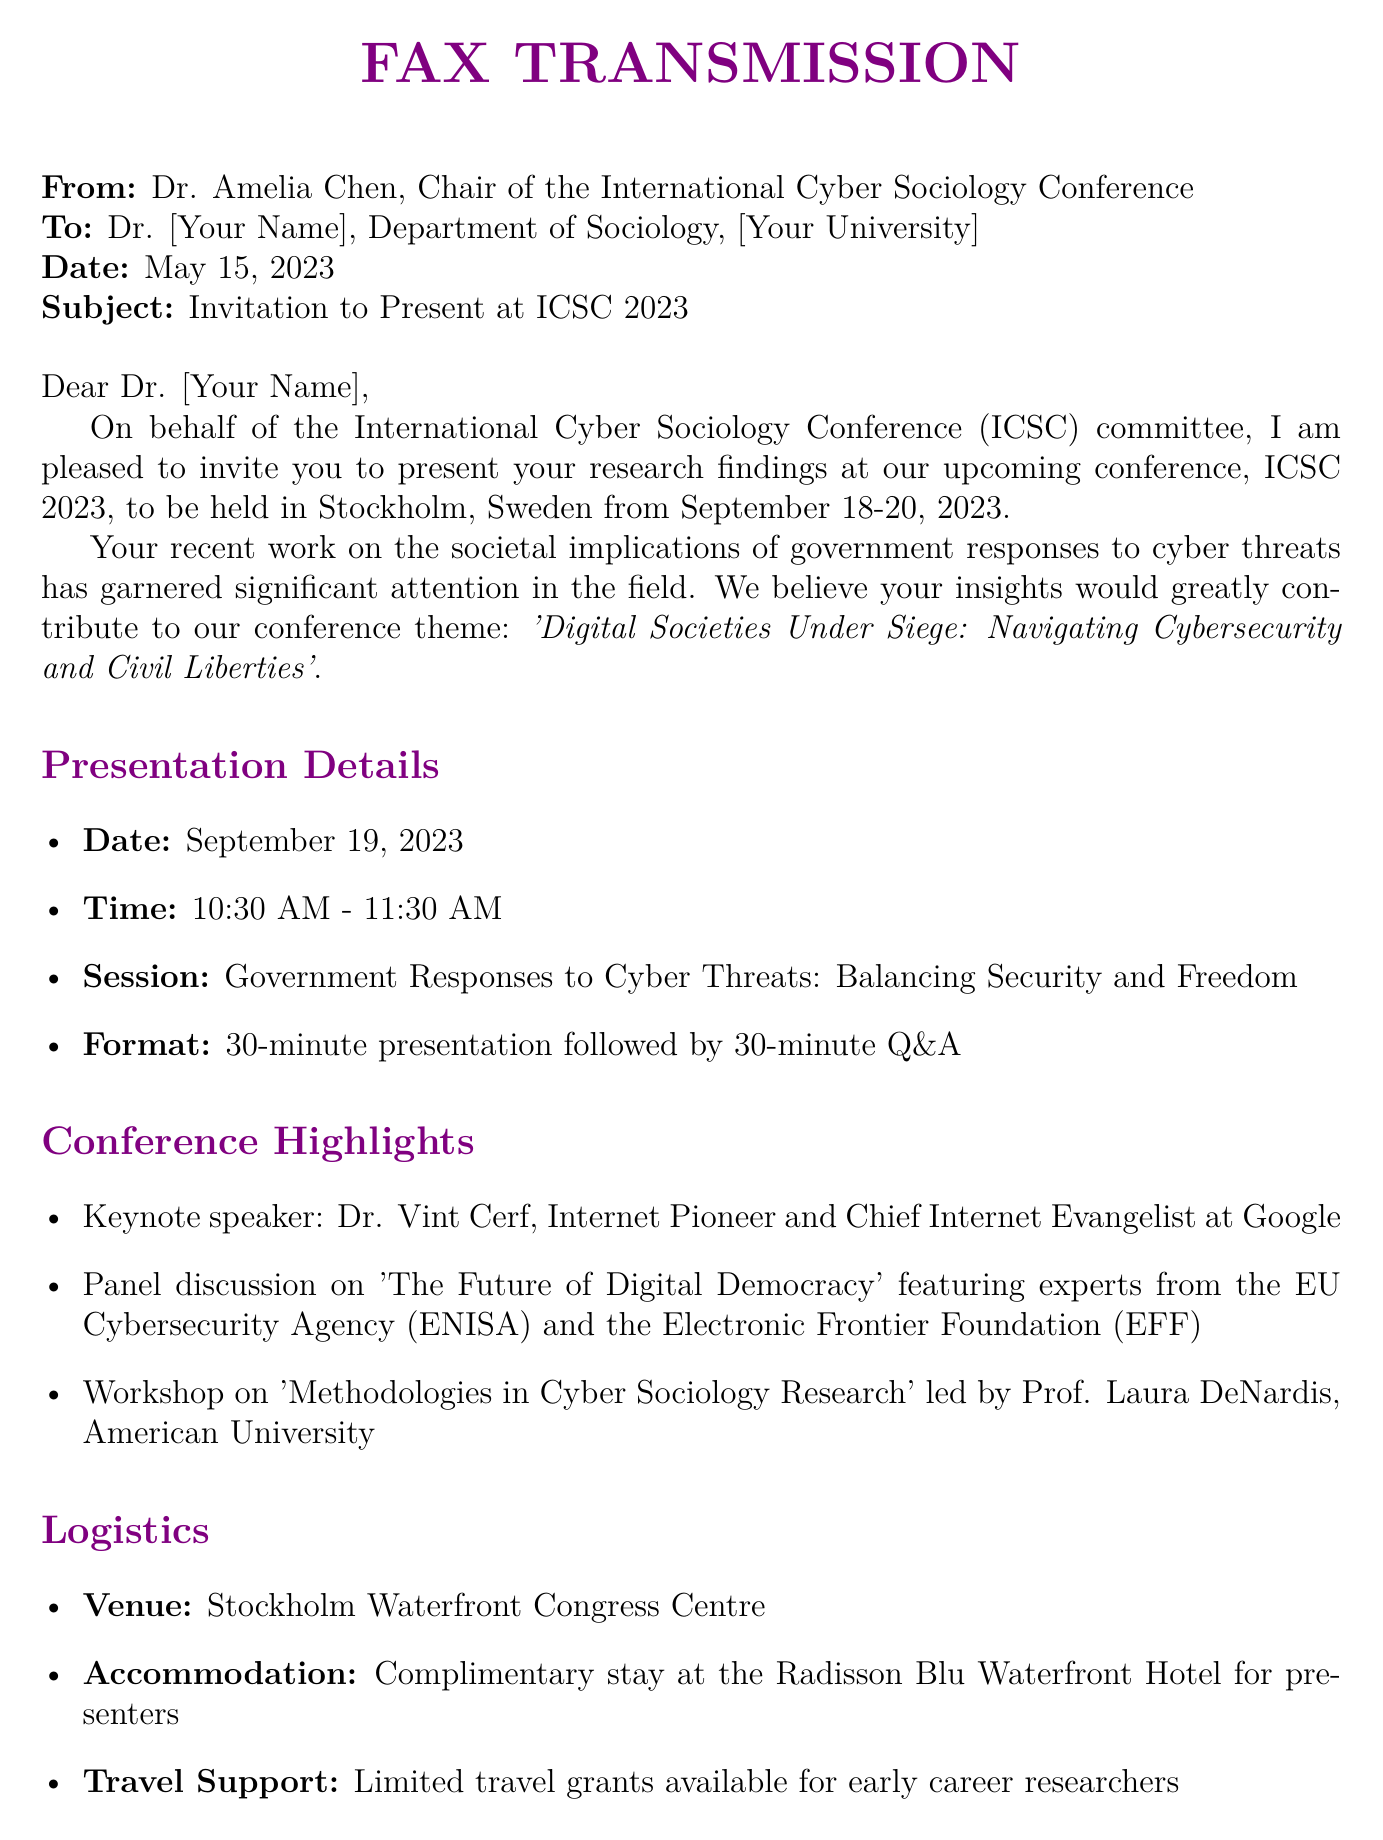What is the date of the conference? The date of the conference is clearly stated in the document as September 18-20, 2023.
Answer: September 18-20, 2023 Who is the keynote speaker? The document explicitly mentions that the keynote speaker is Dr. Vint Cerf.
Answer: Dr. Vint Cerf Which hotel offers complimentary accommodation for presenters? The document specifies the Radisson Blu Waterfront Hotel as the hotel providing complimentary accommodation.
Answer: Radisson Blu Waterfront Hotel What is the time allocated for the presentation? The time allocated for the presentation is described in the document as a 30-minute presentation followed by a 30-minute Q&A.
Answer: 30 minutes What is the theme of the conference? The theme is mentioned in the document as 'Digital Societies Under Siege: Navigating Cybersecurity and Civil Liberties'.
Answer: Digital Societies Under Siege: Navigating Cybersecurity and Civil Liberties What is the deadline to confirm participation? The document indicates that the deadline to confirm participation is June 15, 2023.
Answer: June 15, 2023 How long is the Q&A session after the presentation? The document directly states that the Q&A session is 30 minutes long following the presentation.
Answer: 30 minutes What session does the presented research fall under? The document categorizes the session as 'Government Responses to Cyber Threats: Balancing Security and Freedom'.
Answer: Government Responses to Cyber Threats: Balancing Security and Freedom What is the venue for the conference? The venue is listed in the document as the Stockholm Waterfront Congress Centre.
Answer: Stockholm Waterfront Congress Centre 